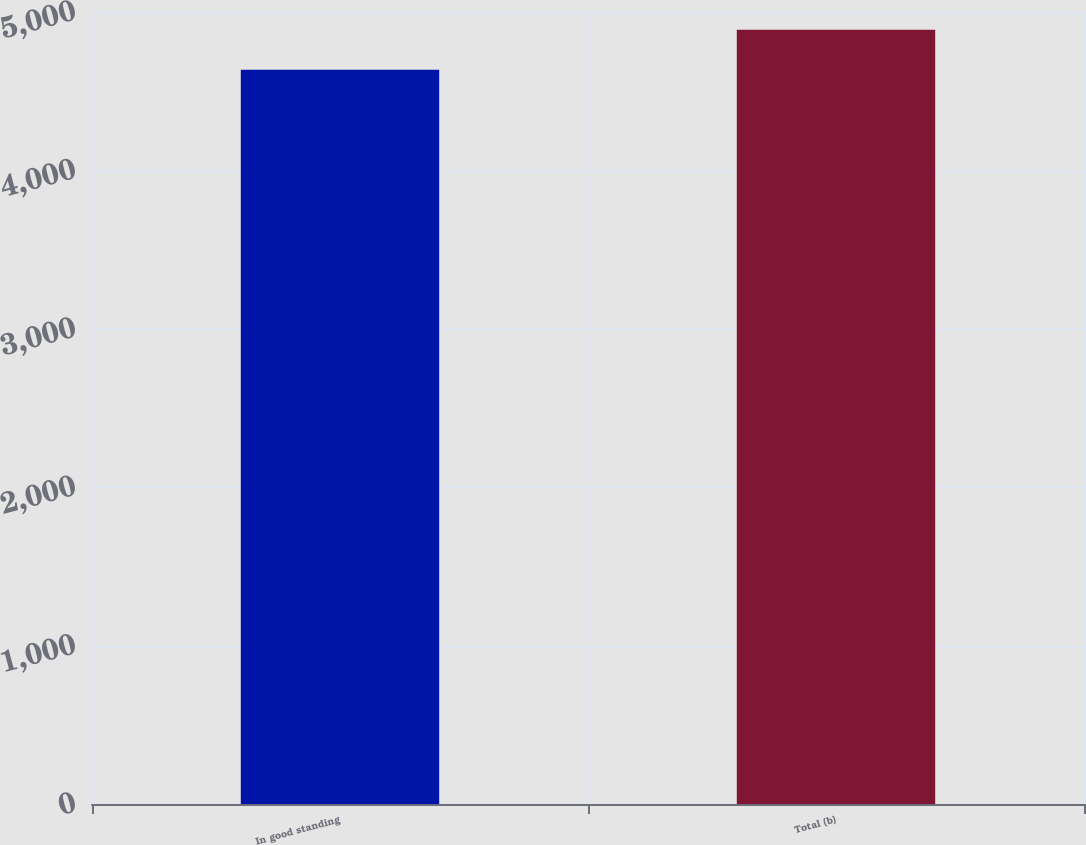Convert chart. <chart><loc_0><loc_0><loc_500><loc_500><bar_chart><fcel>In good standing<fcel>Total (b)<nl><fcel>4636<fcel>4888<nl></chart> 